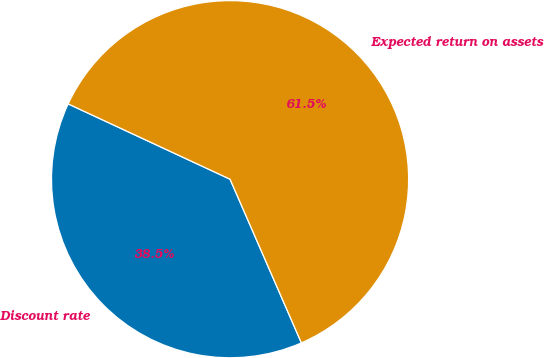Convert chart to OTSL. <chart><loc_0><loc_0><loc_500><loc_500><pie_chart><fcel>Discount rate<fcel>Expected return on assets<nl><fcel>38.47%<fcel>61.53%<nl></chart> 